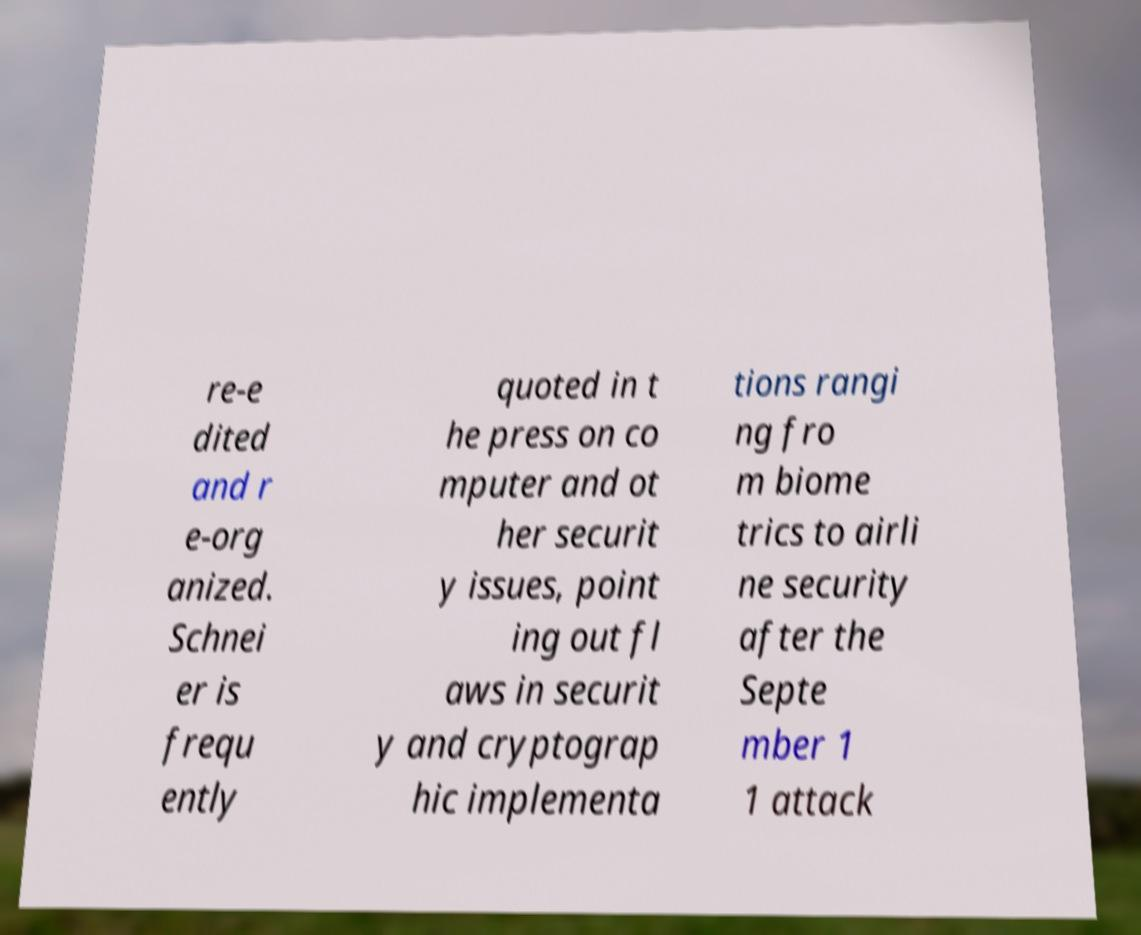There's text embedded in this image that I need extracted. Can you transcribe it verbatim? re-e dited and r e-org anized. Schnei er is frequ ently quoted in t he press on co mputer and ot her securit y issues, point ing out fl aws in securit y and cryptograp hic implementa tions rangi ng fro m biome trics to airli ne security after the Septe mber 1 1 attack 